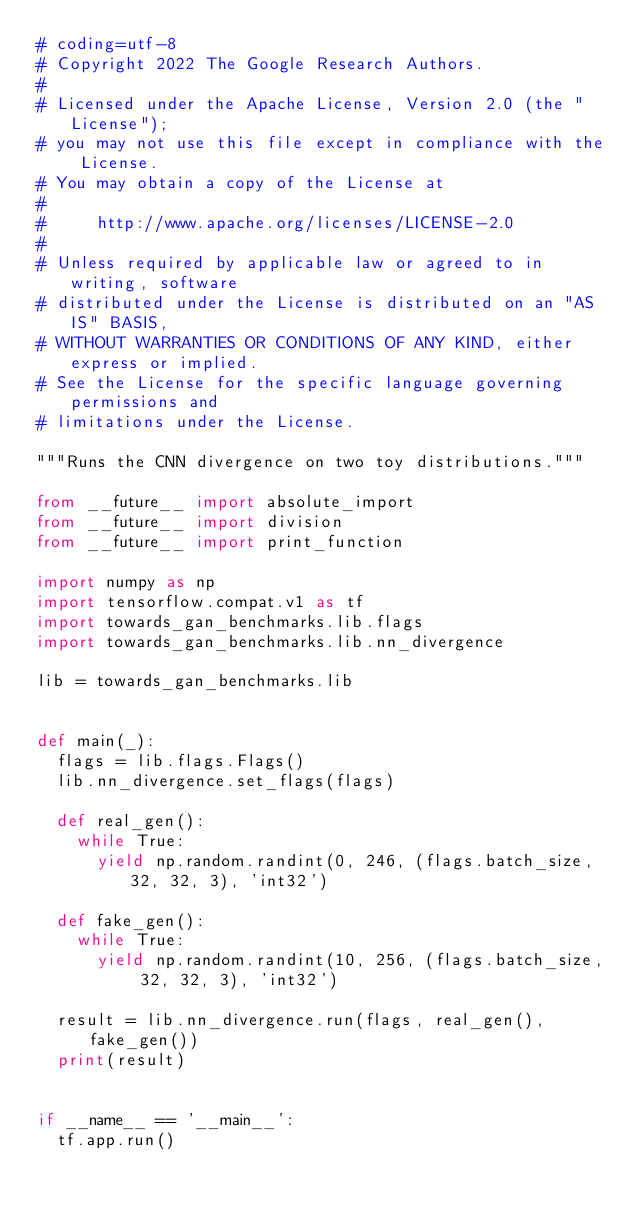Convert code to text. <code><loc_0><loc_0><loc_500><loc_500><_Python_># coding=utf-8
# Copyright 2022 The Google Research Authors.
#
# Licensed under the Apache License, Version 2.0 (the "License");
# you may not use this file except in compliance with the License.
# You may obtain a copy of the License at
#
#     http://www.apache.org/licenses/LICENSE-2.0
#
# Unless required by applicable law or agreed to in writing, software
# distributed under the License is distributed on an "AS IS" BASIS,
# WITHOUT WARRANTIES OR CONDITIONS OF ANY KIND, either express or implied.
# See the License for the specific language governing permissions and
# limitations under the License.

"""Runs the CNN divergence on two toy distributions."""

from __future__ import absolute_import
from __future__ import division
from __future__ import print_function

import numpy as np
import tensorflow.compat.v1 as tf
import towards_gan_benchmarks.lib.flags
import towards_gan_benchmarks.lib.nn_divergence

lib = towards_gan_benchmarks.lib


def main(_):
  flags = lib.flags.Flags()
  lib.nn_divergence.set_flags(flags)

  def real_gen():
    while True:
      yield np.random.randint(0, 246, (flags.batch_size, 32, 32, 3), 'int32')

  def fake_gen():
    while True:
      yield np.random.randint(10, 256, (flags.batch_size, 32, 32, 3), 'int32')

  result = lib.nn_divergence.run(flags, real_gen(), fake_gen())
  print(result)


if __name__ == '__main__':
  tf.app.run()
</code> 